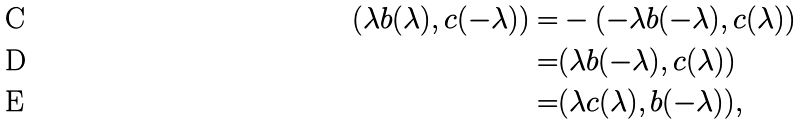Convert formula to latex. <formula><loc_0><loc_0><loc_500><loc_500>( \lambda b ( \lambda ) , c ( - \lambda ) ) = & - ( - \lambda b ( - \lambda ) , c ( \lambda ) ) \\ = & ( \lambda b ( - \lambda ) , c ( \lambda ) ) \\ = & ( \lambda c ( \lambda ) , b ( - \lambda ) ) ,</formula> 